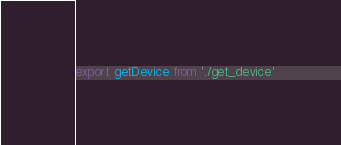<code> <loc_0><loc_0><loc_500><loc_500><_JavaScript_>export getDevice from './get_device'
</code> 